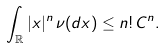Convert formula to latex. <formula><loc_0><loc_0><loc_500><loc_500>\int _ { \mathbb { R } } | x | ^ { n } \, \nu ( d x ) \leq n ! \, C ^ { n } .</formula> 